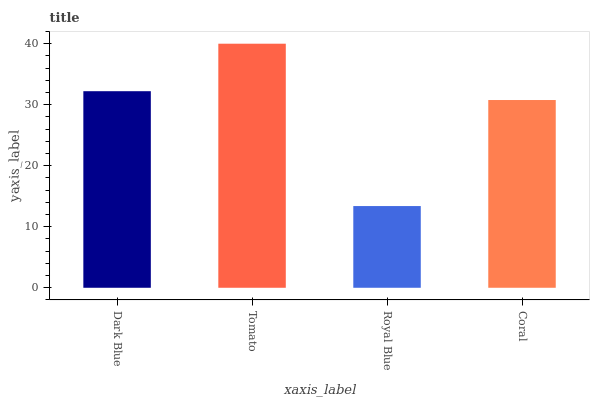Is Tomato the minimum?
Answer yes or no. No. Is Royal Blue the maximum?
Answer yes or no. No. Is Tomato greater than Royal Blue?
Answer yes or no. Yes. Is Royal Blue less than Tomato?
Answer yes or no. Yes. Is Royal Blue greater than Tomato?
Answer yes or no. No. Is Tomato less than Royal Blue?
Answer yes or no. No. Is Dark Blue the high median?
Answer yes or no. Yes. Is Coral the low median?
Answer yes or no. Yes. Is Tomato the high median?
Answer yes or no. No. Is Royal Blue the low median?
Answer yes or no. No. 